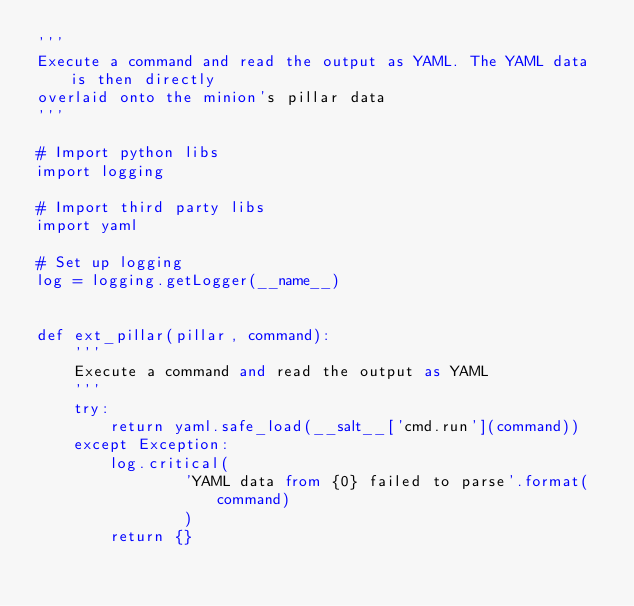<code> <loc_0><loc_0><loc_500><loc_500><_Python_>'''
Execute a command and read the output as YAML. The YAML data is then directly
overlaid onto the minion's pillar data
'''

# Import python libs
import logging

# Import third party libs
import yaml

# Set up logging
log = logging.getLogger(__name__)


def ext_pillar(pillar, command):
    '''
    Execute a command and read the output as YAML
    '''
    try:
        return yaml.safe_load(__salt__['cmd.run'](command))
    except Exception:
        log.critical(
                'YAML data from {0} failed to parse'.format(command)
                )
        return {}
</code> 